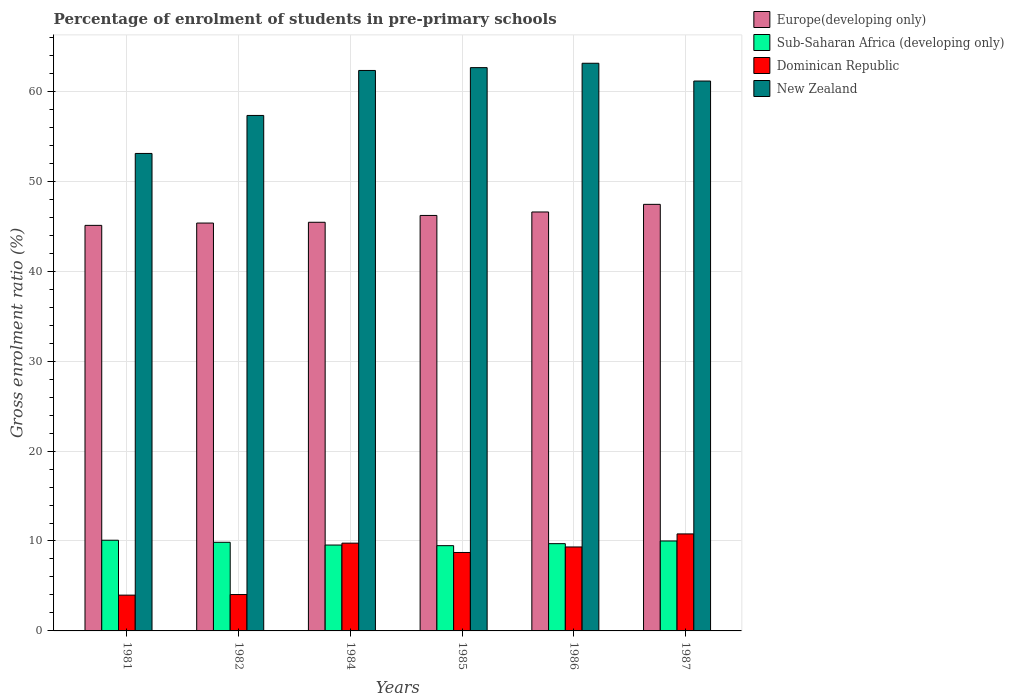How many different coloured bars are there?
Offer a terse response. 4. How many groups of bars are there?
Give a very brief answer. 6. Are the number of bars per tick equal to the number of legend labels?
Offer a terse response. Yes. Are the number of bars on each tick of the X-axis equal?
Give a very brief answer. Yes. How many bars are there on the 5th tick from the left?
Provide a succinct answer. 4. How many bars are there on the 5th tick from the right?
Keep it short and to the point. 4. In how many cases, is the number of bars for a given year not equal to the number of legend labels?
Offer a terse response. 0. What is the percentage of students enrolled in pre-primary schools in Sub-Saharan Africa (developing only) in 1982?
Keep it short and to the point. 9.86. Across all years, what is the maximum percentage of students enrolled in pre-primary schools in Dominican Republic?
Give a very brief answer. 10.79. Across all years, what is the minimum percentage of students enrolled in pre-primary schools in Sub-Saharan Africa (developing only)?
Give a very brief answer. 9.48. In which year was the percentage of students enrolled in pre-primary schools in Europe(developing only) maximum?
Offer a terse response. 1987. What is the total percentage of students enrolled in pre-primary schools in Europe(developing only) in the graph?
Keep it short and to the point. 276.12. What is the difference between the percentage of students enrolled in pre-primary schools in Dominican Republic in 1984 and that in 1985?
Provide a succinct answer. 1.04. What is the difference between the percentage of students enrolled in pre-primary schools in Dominican Republic in 1986 and the percentage of students enrolled in pre-primary schools in New Zealand in 1985?
Ensure brevity in your answer.  -53.3. What is the average percentage of students enrolled in pre-primary schools in Europe(developing only) per year?
Provide a short and direct response. 46.02. In the year 1981, what is the difference between the percentage of students enrolled in pre-primary schools in New Zealand and percentage of students enrolled in pre-primary schools in Dominican Republic?
Your response must be concise. 49.12. In how many years, is the percentage of students enrolled in pre-primary schools in New Zealand greater than 36 %?
Your response must be concise. 6. What is the ratio of the percentage of students enrolled in pre-primary schools in Dominican Republic in 1981 to that in 1982?
Your response must be concise. 0.98. Is the percentage of students enrolled in pre-primary schools in Europe(developing only) in 1982 less than that in 1986?
Your answer should be compact. Yes. Is the difference between the percentage of students enrolled in pre-primary schools in New Zealand in 1982 and 1986 greater than the difference between the percentage of students enrolled in pre-primary schools in Dominican Republic in 1982 and 1986?
Provide a succinct answer. No. What is the difference between the highest and the second highest percentage of students enrolled in pre-primary schools in Sub-Saharan Africa (developing only)?
Your response must be concise. 0.08. What is the difference between the highest and the lowest percentage of students enrolled in pre-primary schools in Dominican Republic?
Provide a succinct answer. 6.81. In how many years, is the percentage of students enrolled in pre-primary schools in New Zealand greater than the average percentage of students enrolled in pre-primary schools in New Zealand taken over all years?
Your response must be concise. 4. Is it the case that in every year, the sum of the percentage of students enrolled in pre-primary schools in Dominican Republic and percentage of students enrolled in pre-primary schools in Europe(developing only) is greater than the sum of percentage of students enrolled in pre-primary schools in New Zealand and percentage of students enrolled in pre-primary schools in Sub-Saharan Africa (developing only)?
Make the answer very short. Yes. What does the 4th bar from the left in 1984 represents?
Offer a very short reply. New Zealand. What does the 3rd bar from the right in 1987 represents?
Your response must be concise. Sub-Saharan Africa (developing only). Is it the case that in every year, the sum of the percentage of students enrolled in pre-primary schools in Dominican Republic and percentage of students enrolled in pre-primary schools in Sub-Saharan Africa (developing only) is greater than the percentage of students enrolled in pre-primary schools in New Zealand?
Give a very brief answer. No. How many bars are there?
Give a very brief answer. 24. Are all the bars in the graph horizontal?
Keep it short and to the point. No. How many years are there in the graph?
Ensure brevity in your answer.  6. Are the values on the major ticks of Y-axis written in scientific E-notation?
Ensure brevity in your answer.  No. Does the graph contain grids?
Your response must be concise. Yes. What is the title of the graph?
Provide a short and direct response. Percentage of enrolment of students in pre-primary schools. What is the label or title of the X-axis?
Offer a very short reply. Years. What is the label or title of the Y-axis?
Offer a very short reply. Gross enrolment ratio (%). What is the Gross enrolment ratio (%) of Europe(developing only) in 1981?
Make the answer very short. 45.1. What is the Gross enrolment ratio (%) of Sub-Saharan Africa (developing only) in 1981?
Your answer should be very brief. 10.09. What is the Gross enrolment ratio (%) of Dominican Republic in 1981?
Provide a short and direct response. 3.98. What is the Gross enrolment ratio (%) in New Zealand in 1981?
Your answer should be compact. 53.1. What is the Gross enrolment ratio (%) of Europe(developing only) in 1982?
Offer a very short reply. 45.35. What is the Gross enrolment ratio (%) in Sub-Saharan Africa (developing only) in 1982?
Keep it short and to the point. 9.86. What is the Gross enrolment ratio (%) in Dominican Republic in 1982?
Give a very brief answer. 4.05. What is the Gross enrolment ratio (%) in New Zealand in 1982?
Provide a succinct answer. 57.32. What is the Gross enrolment ratio (%) of Europe(developing only) in 1984?
Keep it short and to the point. 45.44. What is the Gross enrolment ratio (%) in Sub-Saharan Africa (developing only) in 1984?
Your response must be concise. 9.55. What is the Gross enrolment ratio (%) in Dominican Republic in 1984?
Your answer should be compact. 9.76. What is the Gross enrolment ratio (%) in New Zealand in 1984?
Your answer should be very brief. 62.32. What is the Gross enrolment ratio (%) in Europe(developing only) in 1985?
Provide a short and direct response. 46.2. What is the Gross enrolment ratio (%) of Sub-Saharan Africa (developing only) in 1985?
Ensure brevity in your answer.  9.48. What is the Gross enrolment ratio (%) in Dominican Republic in 1985?
Your answer should be very brief. 8.72. What is the Gross enrolment ratio (%) of New Zealand in 1985?
Offer a very short reply. 62.64. What is the Gross enrolment ratio (%) in Europe(developing only) in 1986?
Offer a very short reply. 46.59. What is the Gross enrolment ratio (%) in Sub-Saharan Africa (developing only) in 1986?
Provide a succinct answer. 9.7. What is the Gross enrolment ratio (%) of Dominican Republic in 1986?
Give a very brief answer. 9.34. What is the Gross enrolment ratio (%) of New Zealand in 1986?
Make the answer very short. 63.12. What is the Gross enrolment ratio (%) of Europe(developing only) in 1987?
Keep it short and to the point. 47.43. What is the Gross enrolment ratio (%) of Sub-Saharan Africa (developing only) in 1987?
Offer a terse response. 10. What is the Gross enrolment ratio (%) in Dominican Republic in 1987?
Make the answer very short. 10.79. What is the Gross enrolment ratio (%) in New Zealand in 1987?
Provide a succinct answer. 61.15. Across all years, what is the maximum Gross enrolment ratio (%) in Europe(developing only)?
Your response must be concise. 47.43. Across all years, what is the maximum Gross enrolment ratio (%) of Sub-Saharan Africa (developing only)?
Offer a very short reply. 10.09. Across all years, what is the maximum Gross enrolment ratio (%) of Dominican Republic?
Provide a short and direct response. 10.79. Across all years, what is the maximum Gross enrolment ratio (%) of New Zealand?
Provide a short and direct response. 63.12. Across all years, what is the minimum Gross enrolment ratio (%) of Europe(developing only)?
Your response must be concise. 45.1. Across all years, what is the minimum Gross enrolment ratio (%) in Sub-Saharan Africa (developing only)?
Ensure brevity in your answer.  9.48. Across all years, what is the minimum Gross enrolment ratio (%) in Dominican Republic?
Make the answer very short. 3.98. Across all years, what is the minimum Gross enrolment ratio (%) of New Zealand?
Provide a succinct answer. 53.1. What is the total Gross enrolment ratio (%) of Europe(developing only) in the graph?
Your response must be concise. 276.12. What is the total Gross enrolment ratio (%) of Sub-Saharan Africa (developing only) in the graph?
Offer a very short reply. 58.68. What is the total Gross enrolment ratio (%) in Dominican Republic in the graph?
Make the answer very short. 46.63. What is the total Gross enrolment ratio (%) in New Zealand in the graph?
Your answer should be compact. 359.65. What is the difference between the Gross enrolment ratio (%) in Europe(developing only) in 1981 and that in 1982?
Make the answer very short. -0.26. What is the difference between the Gross enrolment ratio (%) in Sub-Saharan Africa (developing only) in 1981 and that in 1982?
Provide a short and direct response. 0.23. What is the difference between the Gross enrolment ratio (%) of Dominican Republic in 1981 and that in 1982?
Provide a succinct answer. -0.07. What is the difference between the Gross enrolment ratio (%) of New Zealand in 1981 and that in 1982?
Offer a very short reply. -4.22. What is the difference between the Gross enrolment ratio (%) in Europe(developing only) in 1981 and that in 1984?
Your answer should be compact. -0.34. What is the difference between the Gross enrolment ratio (%) of Sub-Saharan Africa (developing only) in 1981 and that in 1984?
Make the answer very short. 0.54. What is the difference between the Gross enrolment ratio (%) of Dominican Republic in 1981 and that in 1984?
Your answer should be very brief. -5.78. What is the difference between the Gross enrolment ratio (%) of New Zealand in 1981 and that in 1984?
Offer a terse response. -9.23. What is the difference between the Gross enrolment ratio (%) in Europe(developing only) in 1981 and that in 1985?
Your answer should be very brief. -1.1. What is the difference between the Gross enrolment ratio (%) in Sub-Saharan Africa (developing only) in 1981 and that in 1985?
Ensure brevity in your answer.  0.61. What is the difference between the Gross enrolment ratio (%) in Dominican Republic in 1981 and that in 1985?
Ensure brevity in your answer.  -4.74. What is the difference between the Gross enrolment ratio (%) of New Zealand in 1981 and that in 1985?
Offer a terse response. -9.54. What is the difference between the Gross enrolment ratio (%) of Europe(developing only) in 1981 and that in 1986?
Give a very brief answer. -1.49. What is the difference between the Gross enrolment ratio (%) of Sub-Saharan Africa (developing only) in 1981 and that in 1986?
Offer a very short reply. 0.38. What is the difference between the Gross enrolment ratio (%) in Dominican Republic in 1981 and that in 1986?
Your answer should be compact. -5.36. What is the difference between the Gross enrolment ratio (%) of New Zealand in 1981 and that in 1986?
Your answer should be very brief. -10.03. What is the difference between the Gross enrolment ratio (%) in Europe(developing only) in 1981 and that in 1987?
Provide a succinct answer. -2.34. What is the difference between the Gross enrolment ratio (%) of Sub-Saharan Africa (developing only) in 1981 and that in 1987?
Give a very brief answer. 0.08. What is the difference between the Gross enrolment ratio (%) of Dominican Republic in 1981 and that in 1987?
Your answer should be very brief. -6.81. What is the difference between the Gross enrolment ratio (%) of New Zealand in 1981 and that in 1987?
Your answer should be very brief. -8.05. What is the difference between the Gross enrolment ratio (%) in Europe(developing only) in 1982 and that in 1984?
Make the answer very short. -0.09. What is the difference between the Gross enrolment ratio (%) of Sub-Saharan Africa (developing only) in 1982 and that in 1984?
Your answer should be compact. 0.31. What is the difference between the Gross enrolment ratio (%) in Dominican Republic in 1982 and that in 1984?
Ensure brevity in your answer.  -5.72. What is the difference between the Gross enrolment ratio (%) of New Zealand in 1982 and that in 1984?
Provide a short and direct response. -5. What is the difference between the Gross enrolment ratio (%) of Europe(developing only) in 1982 and that in 1985?
Offer a terse response. -0.85. What is the difference between the Gross enrolment ratio (%) in Sub-Saharan Africa (developing only) in 1982 and that in 1985?
Provide a short and direct response. 0.38. What is the difference between the Gross enrolment ratio (%) of Dominican Republic in 1982 and that in 1985?
Ensure brevity in your answer.  -4.68. What is the difference between the Gross enrolment ratio (%) of New Zealand in 1982 and that in 1985?
Provide a short and direct response. -5.32. What is the difference between the Gross enrolment ratio (%) in Europe(developing only) in 1982 and that in 1986?
Provide a succinct answer. -1.23. What is the difference between the Gross enrolment ratio (%) of Sub-Saharan Africa (developing only) in 1982 and that in 1986?
Your answer should be very brief. 0.15. What is the difference between the Gross enrolment ratio (%) of Dominican Republic in 1982 and that in 1986?
Give a very brief answer. -5.29. What is the difference between the Gross enrolment ratio (%) of New Zealand in 1982 and that in 1986?
Offer a terse response. -5.8. What is the difference between the Gross enrolment ratio (%) of Europe(developing only) in 1982 and that in 1987?
Ensure brevity in your answer.  -2.08. What is the difference between the Gross enrolment ratio (%) in Sub-Saharan Africa (developing only) in 1982 and that in 1987?
Your response must be concise. -0.15. What is the difference between the Gross enrolment ratio (%) of Dominican Republic in 1982 and that in 1987?
Your answer should be very brief. -6.74. What is the difference between the Gross enrolment ratio (%) of New Zealand in 1982 and that in 1987?
Your answer should be compact. -3.83. What is the difference between the Gross enrolment ratio (%) in Europe(developing only) in 1984 and that in 1985?
Ensure brevity in your answer.  -0.76. What is the difference between the Gross enrolment ratio (%) in Sub-Saharan Africa (developing only) in 1984 and that in 1985?
Your answer should be very brief. 0.07. What is the difference between the Gross enrolment ratio (%) of Dominican Republic in 1984 and that in 1985?
Ensure brevity in your answer.  1.04. What is the difference between the Gross enrolment ratio (%) of New Zealand in 1984 and that in 1985?
Provide a succinct answer. -0.31. What is the difference between the Gross enrolment ratio (%) of Europe(developing only) in 1984 and that in 1986?
Your answer should be very brief. -1.14. What is the difference between the Gross enrolment ratio (%) in Sub-Saharan Africa (developing only) in 1984 and that in 1986?
Keep it short and to the point. -0.15. What is the difference between the Gross enrolment ratio (%) of Dominican Republic in 1984 and that in 1986?
Give a very brief answer. 0.42. What is the difference between the Gross enrolment ratio (%) in New Zealand in 1984 and that in 1986?
Provide a short and direct response. -0.8. What is the difference between the Gross enrolment ratio (%) in Europe(developing only) in 1984 and that in 1987?
Offer a terse response. -1.99. What is the difference between the Gross enrolment ratio (%) in Sub-Saharan Africa (developing only) in 1984 and that in 1987?
Give a very brief answer. -0.45. What is the difference between the Gross enrolment ratio (%) of Dominican Republic in 1984 and that in 1987?
Keep it short and to the point. -1.03. What is the difference between the Gross enrolment ratio (%) in New Zealand in 1984 and that in 1987?
Provide a short and direct response. 1.18. What is the difference between the Gross enrolment ratio (%) in Europe(developing only) in 1985 and that in 1986?
Your response must be concise. -0.39. What is the difference between the Gross enrolment ratio (%) in Sub-Saharan Africa (developing only) in 1985 and that in 1986?
Ensure brevity in your answer.  -0.22. What is the difference between the Gross enrolment ratio (%) in Dominican Republic in 1985 and that in 1986?
Your answer should be very brief. -0.61. What is the difference between the Gross enrolment ratio (%) in New Zealand in 1985 and that in 1986?
Keep it short and to the point. -0.49. What is the difference between the Gross enrolment ratio (%) in Europe(developing only) in 1985 and that in 1987?
Offer a terse response. -1.23. What is the difference between the Gross enrolment ratio (%) in Sub-Saharan Africa (developing only) in 1985 and that in 1987?
Your response must be concise. -0.52. What is the difference between the Gross enrolment ratio (%) in Dominican Republic in 1985 and that in 1987?
Make the answer very short. -2.06. What is the difference between the Gross enrolment ratio (%) in New Zealand in 1985 and that in 1987?
Your answer should be compact. 1.49. What is the difference between the Gross enrolment ratio (%) of Europe(developing only) in 1986 and that in 1987?
Your response must be concise. -0.85. What is the difference between the Gross enrolment ratio (%) in Sub-Saharan Africa (developing only) in 1986 and that in 1987?
Provide a succinct answer. -0.3. What is the difference between the Gross enrolment ratio (%) in Dominican Republic in 1986 and that in 1987?
Your response must be concise. -1.45. What is the difference between the Gross enrolment ratio (%) of New Zealand in 1986 and that in 1987?
Your answer should be compact. 1.98. What is the difference between the Gross enrolment ratio (%) in Europe(developing only) in 1981 and the Gross enrolment ratio (%) in Sub-Saharan Africa (developing only) in 1982?
Ensure brevity in your answer.  35.24. What is the difference between the Gross enrolment ratio (%) of Europe(developing only) in 1981 and the Gross enrolment ratio (%) of Dominican Republic in 1982?
Your response must be concise. 41.05. What is the difference between the Gross enrolment ratio (%) in Europe(developing only) in 1981 and the Gross enrolment ratio (%) in New Zealand in 1982?
Offer a terse response. -12.22. What is the difference between the Gross enrolment ratio (%) of Sub-Saharan Africa (developing only) in 1981 and the Gross enrolment ratio (%) of Dominican Republic in 1982?
Offer a very short reply. 6.04. What is the difference between the Gross enrolment ratio (%) in Sub-Saharan Africa (developing only) in 1981 and the Gross enrolment ratio (%) in New Zealand in 1982?
Make the answer very short. -47.23. What is the difference between the Gross enrolment ratio (%) of Dominican Republic in 1981 and the Gross enrolment ratio (%) of New Zealand in 1982?
Your answer should be compact. -53.34. What is the difference between the Gross enrolment ratio (%) of Europe(developing only) in 1981 and the Gross enrolment ratio (%) of Sub-Saharan Africa (developing only) in 1984?
Provide a succinct answer. 35.55. What is the difference between the Gross enrolment ratio (%) in Europe(developing only) in 1981 and the Gross enrolment ratio (%) in Dominican Republic in 1984?
Give a very brief answer. 35.34. What is the difference between the Gross enrolment ratio (%) in Europe(developing only) in 1981 and the Gross enrolment ratio (%) in New Zealand in 1984?
Provide a short and direct response. -17.23. What is the difference between the Gross enrolment ratio (%) in Sub-Saharan Africa (developing only) in 1981 and the Gross enrolment ratio (%) in Dominican Republic in 1984?
Offer a terse response. 0.33. What is the difference between the Gross enrolment ratio (%) in Sub-Saharan Africa (developing only) in 1981 and the Gross enrolment ratio (%) in New Zealand in 1984?
Offer a very short reply. -52.24. What is the difference between the Gross enrolment ratio (%) of Dominican Republic in 1981 and the Gross enrolment ratio (%) of New Zealand in 1984?
Make the answer very short. -58.34. What is the difference between the Gross enrolment ratio (%) of Europe(developing only) in 1981 and the Gross enrolment ratio (%) of Sub-Saharan Africa (developing only) in 1985?
Provide a succinct answer. 35.62. What is the difference between the Gross enrolment ratio (%) in Europe(developing only) in 1981 and the Gross enrolment ratio (%) in Dominican Republic in 1985?
Offer a very short reply. 36.37. What is the difference between the Gross enrolment ratio (%) of Europe(developing only) in 1981 and the Gross enrolment ratio (%) of New Zealand in 1985?
Ensure brevity in your answer.  -17.54. What is the difference between the Gross enrolment ratio (%) in Sub-Saharan Africa (developing only) in 1981 and the Gross enrolment ratio (%) in Dominican Republic in 1985?
Your answer should be compact. 1.36. What is the difference between the Gross enrolment ratio (%) of Sub-Saharan Africa (developing only) in 1981 and the Gross enrolment ratio (%) of New Zealand in 1985?
Your answer should be compact. -52.55. What is the difference between the Gross enrolment ratio (%) of Dominican Republic in 1981 and the Gross enrolment ratio (%) of New Zealand in 1985?
Keep it short and to the point. -58.66. What is the difference between the Gross enrolment ratio (%) of Europe(developing only) in 1981 and the Gross enrolment ratio (%) of Sub-Saharan Africa (developing only) in 1986?
Your answer should be very brief. 35.39. What is the difference between the Gross enrolment ratio (%) of Europe(developing only) in 1981 and the Gross enrolment ratio (%) of Dominican Republic in 1986?
Provide a short and direct response. 35.76. What is the difference between the Gross enrolment ratio (%) in Europe(developing only) in 1981 and the Gross enrolment ratio (%) in New Zealand in 1986?
Your answer should be very brief. -18.03. What is the difference between the Gross enrolment ratio (%) in Sub-Saharan Africa (developing only) in 1981 and the Gross enrolment ratio (%) in Dominican Republic in 1986?
Offer a very short reply. 0.75. What is the difference between the Gross enrolment ratio (%) of Sub-Saharan Africa (developing only) in 1981 and the Gross enrolment ratio (%) of New Zealand in 1986?
Offer a very short reply. -53.04. What is the difference between the Gross enrolment ratio (%) in Dominican Republic in 1981 and the Gross enrolment ratio (%) in New Zealand in 1986?
Keep it short and to the point. -59.14. What is the difference between the Gross enrolment ratio (%) in Europe(developing only) in 1981 and the Gross enrolment ratio (%) in Sub-Saharan Africa (developing only) in 1987?
Offer a very short reply. 35.1. What is the difference between the Gross enrolment ratio (%) in Europe(developing only) in 1981 and the Gross enrolment ratio (%) in Dominican Republic in 1987?
Your response must be concise. 34.31. What is the difference between the Gross enrolment ratio (%) in Europe(developing only) in 1981 and the Gross enrolment ratio (%) in New Zealand in 1987?
Provide a succinct answer. -16.05. What is the difference between the Gross enrolment ratio (%) of Sub-Saharan Africa (developing only) in 1981 and the Gross enrolment ratio (%) of Dominican Republic in 1987?
Make the answer very short. -0.7. What is the difference between the Gross enrolment ratio (%) of Sub-Saharan Africa (developing only) in 1981 and the Gross enrolment ratio (%) of New Zealand in 1987?
Provide a short and direct response. -51.06. What is the difference between the Gross enrolment ratio (%) in Dominican Republic in 1981 and the Gross enrolment ratio (%) in New Zealand in 1987?
Your answer should be very brief. -57.17. What is the difference between the Gross enrolment ratio (%) in Europe(developing only) in 1982 and the Gross enrolment ratio (%) in Sub-Saharan Africa (developing only) in 1984?
Keep it short and to the point. 35.8. What is the difference between the Gross enrolment ratio (%) in Europe(developing only) in 1982 and the Gross enrolment ratio (%) in Dominican Republic in 1984?
Your response must be concise. 35.59. What is the difference between the Gross enrolment ratio (%) in Europe(developing only) in 1982 and the Gross enrolment ratio (%) in New Zealand in 1984?
Make the answer very short. -16.97. What is the difference between the Gross enrolment ratio (%) of Sub-Saharan Africa (developing only) in 1982 and the Gross enrolment ratio (%) of Dominican Republic in 1984?
Your answer should be compact. 0.1. What is the difference between the Gross enrolment ratio (%) in Sub-Saharan Africa (developing only) in 1982 and the Gross enrolment ratio (%) in New Zealand in 1984?
Your answer should be very brief. -52.47. What is the difference between the Gross enrolment ratio (%) in Dominican Republic in 1982 and the Gross enrolment ratio (%) in New Zealand in 1984?
Your answer should be compact. -58.28. What is the difference between the Gross enrolment ratio (%) in Europe(developing only) in 1982 and the Gross enrolment ratio (%) in Sub-Saharan Africa (developing only) in 1985?
Ensure brevity in your answer.  35.87. What is the difference between the Gross enrolment ratio (%) in Europe(developing only) in 1982 and the Gross enrolment ratio (%) in Dominican Republic in 1985?
Your answer should be very brief. 36.63. What is the difference between the Gross enrolment ratio (%) of Europe(developing only) in 1982 and the Gross enrolment ratio (%) of New Zealand in 1985?
Offer a terse response. -17.28. What is the difference between the Gross enrolment ratio (%) of Sub-Saharan Africa (developing only) in 1982 and the Gross enrolment ratio (%) of Dominican Republic in 1985?
Your answer should be compact. 1.13. What is the difference between the Gross enrolment ratio (%) in Sub-Saharan Africa (developing only) in 1982 and the Gross enrolment ratio (%) in New Zealand in 1985?
Provide a short and direct response. -52.78. What is the difference between the Gross enrolment ratio (%) in Dominican Republic in 1982 and the Gross enrolment ratio (%) in New Zealand in 1985?
Keep it short and to the point. -58.59. What is the difference between the Gross enrolment ratio (%) in Europe(developing only) in 1982 and the Gross enrolment ratio (%) in Sub-Saharan Africa (developing only) in 1986?
Keep it short and to the point. 35.65. What is the difference between the Gross enrolment ratio (%) in Europe(developing only) in 1982 and the Gross enrolment ratio (%) in Dominican Republic in 1986?
Provide a succinct answer. 36.02. What is the difference between the Gross enrolment ratio (%) of Europe(developing only) in 1982 and the Gross enrolment ratio (%) of New Zealand in 1986?
Give a very brief answer. -17.77. What is the difference between the Gross enrolment ratio (%) in Sub-Saharan Africa (developing only) in 1982 and the Gross enrolment ratio (%) in Dominican Republic in 1986?
Your answer should be compact. 0.52. What is the difference between the Gross enrolment ratio (%) of Sub-Saharan Africa (developing only) in 1982 and the Gross enrolment ratio (%) of New Zealand in 1986?
Your answer should be very brief. -53.27. What is the difference between the Gross enrolment ratio (%) in Dominican Republic in 1982 and the Gross enrolment ratio (%) in New Zealand in 1986?
Offer a very short reply. -59.08. What is the difference between the Gross enrolment ratio (%) in Europe(developing only) in 1982 and the Gross enrolment ratio (%) in Sub-Saharan Africa (developing only) in 1987?
Keep it short and to the point. 35.35. What is the difference between the Gross enrolment ratio (%) in Europe(developing only) in 1982 and the Gross enrolment ratio (%) in Dominican Republic in 1987?
Your response must be concise. 34.57. What is the difference between the Gross enrolment ratio (%) in Europe(developing only) in 1982 and the Gross enrolment ratio (%) in New Zealand in 1987?
Your response must be concise. -15.79. What is the difference between the Gross enrolment ratio (%) of Sub-Saharan Africa (developing only) in 1982 and the Gross enrolment ratio (%) of Dominican Republic in 1987?
Your answer should be very brief. -0.93. What is the difference between the Gross enrolment ratio (%) in Sub-Saharan Africa (developing only) in 1982 and the Gross enrolment ratio (%) in New Zealand in 1987?
Your answer should be compact. -51.29. What is the difference between the Gross enrolment ratio (%) of Dominican Republic in 1982 and the Gross enrolment ratio (%) of New Zealand in 1987?
Keep it short and to the point. -57.1. What is the difference between the Gross enrolment ratio (%) of Europe(developing only) in 1984 and the Gross enrolment ratio (%) of Sub-Saharan Africa (developing only) in 1985?
Your answer should be very brief. 35.96. What is the difference between the Gross enrolment ratio (%) of Europe(developing only) in 1984 and the Gross enrolment ratio (%) of Dominican Republic in 1985?
Your answer should be very brief. 36.72. What is the difference between the Gross enrolment ratio (%) of Europe(developing only) in 1984 and the Gross enrolment ratio (%) of New Zealand in 1985?
Your response must be concise. -17.2. What is the difference between the Gross enrolment ratio (%) of Sub-Saharan Africa (developing only) in 1984 and the Gross enrolment ratio (%) of Dominican Republic in 1985?
Keep it short and to the point. 0.83. What is the difference between the Gross enrolment ratio (%) of Sub-Saharan Africa (developing only) in 1984 and the Gross enrolment ratio (%) of New Zealand in 1985?
Keep it short and to the point. -53.09. What is the difference between the Gross enrolment ratio (%) of Dominican Republic in 1984 and the Gross enrolment ratio (%) of New Zealand in 1985?
Provide a succinct answer. -52.88. What is the difference between the Gross enrolment ratio (%) of Europe(developing only) in 1984 and the Gross enrolment ratio (%) of Sub-Saharan Africa (developing only) in 1986?
Your response must be concise. 35.74. What is the difference between the Gross enrolment ratio (%) in Europe(developing only) in 1984 and the Gross enrolment ratio (%) in Dominican Republic in 1986?
Ensure brevity in your answer.  36.11. What is the difference between the Gross enrolment ratio (%) in Europe(developing only) in 1984 and the Gross enrolment ratio (%) in New Zealand in 1986?
Provide a short and direct response. -17.68. What is the difference between the Gross enrolment ratio (%) in Sub-Saharan Africa (developing only) in 1984 and the Gross enrolment ratio (%) in Dominican Republic in 1986?
Your response must be concise. 0.21. What is the difference between the Gross enrolment ratio (%) of Sub-Saharan Africa (developing only) in 1984 and the Gross enrolment ratio (%) of New Zealand in 1986?
Offer a very short reply. -53.57. What is the difference between the Gross enrolment ratio (%) in Dominican Republic in 1984 and the Gross enrolment ratio (%) in New Zealand in 1986?
Make the answer very short. -53.36. What is the difference between the Gross enrolment ratio (%) of Europe(developing only) in 1984 and the Gross enrolment ratio (%) of Sub-Saharan Africa (developing only) in 1987?
Provide a short and direct response. 35.44. What is the difference between the Gross enrolment ratio (%) of Europe(developing only) in 1984 and the Gross enrolment ratio (%) of Dominican Republic in 1987?
Your answer should be very brief. 34.65. What is the difference between the Gross enrolment ratio (%) in Europe(developing only) in 1984 and the Gross enrolment ratio (%) in New Zealand in 1987?
Your response must be concise. -15.7. What is the difference between the Gross enrolment ratio (%) in Sub-Saharan Africa (developing only) in 1984 and the Gross enrolment ratio (%) in Dominican Republic in 1987?
Offer a terse response. -1.24. What is the difference between the Gross enrolment ratio (%) of Sub-Saharan Africa (developing only) in 1984 and the Gross enrolment ratio (%) of New Zealand in 1987?
Give a very brief answer. -51.6. What is the difference between the Gross enrolment ratio (%) in Dominican Republic in 1984 and the Gross enrolment ratio (%) in New Zealand in 1987?
Your response must be concise. -51.39. What is the difference between the Gross enrolment ratio (%) in Europe(developing only) in 1985 and the Gross enrolment ratio (%) in Sub-Saharan Africa (developing only) in 1986?
Give a very brief answer. 36.5. What is the difference between the Gross enrolment ratio (%) in Europe(developing only) in 1985 and the Gross enrolment ratio (%) in Dominican Republic in 1986?
Provide a short and direct response. 36.86. What is the difference between the Gross enrolment ratio (%) in Europe(developing only) in 1985 and the Gross enrolment ratio (%) in New Zealand in 1986?
Make the answer very short. -16.92. What is the difference between the Gross enrolment ratio (%) of Sub-Saharan Africa (developing only) in 1985 and the Gross enrolment ratio (%) of Dominican Republic in 1986?
Give a very brief answer. 0.15. What is the difference between the Gross enrolment ratio (%) in Sub-Saharan Africa (developing only) in 1985 and the Gross enrolment ratio (%) in New Zealand in 1986?
Make the answer very short. -53.64. What is the difference between the Gross enrolment ratio (%) of Dominican Republic in 1985 and the Gross enrolment ratio (%) of New Zealand in 1986?
Keep it short and to the point. -54.4. What is the difference between the Gross enrolment ratio (%) of Europe(developing only) in 1985 and the Gross enrolment ratio (%) of Sub-Saharan Africa (developing only) in 1987?
Your answer should be very brief. 36.2. What is the difference between the Gross enrolment ratio (%) in Europe(developing only) in 1985 and the Gross enrolment ratio (%) in Dominican Republic in 1987?
Make the answer very short. 35.41. What is the difference between the Gross enrolment ratio (%) of Europe(developing only) in 1985 and the Gross enrolment ratio (%) of New Zealand in 1987?
Provide a short and direct response. -14.95. What is the difference between the Gross enrolment ratio (%) of Sub-Saharan Africa (developing only) in 1985 and the Gross enrolment ratio (%) of Dominican Republic in 1987?
Give a very brief answer. -1.31. What is the difference between the Gross enrolment ratio (%) in Sub-Saharan Africa (developing only) in 1985 and the Gross enrolment ratio (%) in New Zealand in 1987?
Give a very brief answer. -51.67. What is the difference between the Gross enrolment ratio (%) in Dominican Republic in 1985 and the Gross enrolment ratio (%) in New Zealand in 1987?
Your response must be concise. -52.42. What is the difference between the Gross enrolment ratio (%) of Europe(developing only) in 1986 and the Gross enrolment ratio (%) of Sub-Saharan Africa (developing only) in 1987?
Provide a succinct answer. 36.58. What is the difference between the Gross enrolment ratio (%) of Europe(developing only) in 1986 and the Gross enrolment ratio (%) of Dominican Republic in 1987?
Your response must be concise. 35.8. What is the difference between the Gross enrolment ratio (%) in Europe(developing only) in 1986 and the Gross enrolment ratio (%) in New Zealand in 1987?
Provide a short and direct response. -14.56. What is the difference between the Gross enrolment ratio (%) of Sub-Saharan Africa (developing only) in 1986 and the Gross enrolment ratio (%) of Dominican Republic in 1987?
Offer a very short reply. -1.08. What is the difference between the Gross enrolment ratio (%) of Sub-Saharan Africa (developing only) in 1986 and the Gross enrolment ratio (%) of New Zealand in 1987?
Ensure brevity in your answer.  -51.44. What is the difference between the Gross enrolment ratio (%) of Dominican Republic in 1986 and the Gross enrolment ratio (%) of New Zealand in 1987?
Your response must be concise. -51.81. What is the average Gross enrolment ratio (%) of Europe(developing only) per year?
Make the answer very short. 46.02. What is the average Gross enrolment ratio (%) in Sub-Saharan Africa (developing only) per year?
Your answer should be compact. 9.78. What is the average Gross enrolment ratio (%) of Dominican Republic per year?
Your answer should be compact. 7.77. What is the average Gross enrolment ratio (%) of New Zealand per year?
Provide a short and direct response. 59.94. In the year 1981, what is the difference between the Gross enrolment ratio (%) in Europe(developing only) and Gross enrolment ratio (%) in Sub-Saharan Africa (developing only)?
Offer a very short reply. 35.01. In the year 1981, what is the difference between the Gross enrolment ratio (%) of Europe(developing only) and Gross enrolment ratio (%) of Dominican Republic?
Offer a very short reply. 41.12. In the year 1981, what is the difference between the Gross enrolment ratio (%) in Europe(developing only) and Gross enrolment ratio (%) in New Zealand?
Ensure brevity in your answer.  -8. In the year 1981, what is the difference between the Gross enrolment ratio (%) of Sub-Saharan Africa (developing only) and Gross enrolment ratio (%) of Dominican Republic?
Offer a terse response. 6.11. In the year 1981, what is the difference between the Gross enrolment ratio (%) of Sub-Saharan Africa (developing only) and Gross enrolment ratio (%) of New Zealand?
Your answer should be compact. -43.01. In the year 1981, what is the difference between the Gross enrolment ratio (%) of Dominican Republic and Gross enrolment ratio (%) of New Zealand?
Give a very brief answer. -49.12. In the year 1982, what is the difference between the Gross enrolment ratio (%) of Europe(developing only) and Gross enrolment ratio (%) of Sub-Saharan Africa (developing only)?
Provide a short and direct response. 35.5. In the year 1982, what is the difference between the Gross enrolment ratio (%) of Europe(developing only) and Gross enrolment ratio (%) of Dominican Republic?
Provide a succinct answer. 41.31. In the year 1982, what is the difference between the Gross enrolment ratio (%) in Europe(developing only) and Gross enrolment ratio (%) in New Zealand?
Ensure brevity in your answer.  -11.97. In the year 1982, what is the difference between the Gross enrolment ratio (%) of Sub-Saharan Africa (developing only) and Gross enrolment ratio (%) of Dominican Republic?
Provide a succinct answer. 5.81. In the year 1982, what is the difference between the Gross enrolment ratio (%) in Sub-Saharan Africa (developing only) and Gross enrolment ratio (%) in New Zealand?
Your answer should be very brief. -47.46. In the year 1982, what is the difference between the Gross enrolment ratio (%) in Dominican Republic and Gross enrolment ratio (%) in New Zealand?
Your response must be concise. -53.27. In the year 1984, what is the difference between the Gross enrolment ratio (%) of Europe(developing only) and Gross enrolment ratio (%) of Sub-Saharan Africa (developing only)?
Your response must be concise. 35.89. In the year 1984, what is the difference between the Gross enrolment ratio (%) in Europe(developing only) and Gross enrolment ratio (%) in Dominican Republic?
Offer a terse response. 35.68. In the year 1984, what is the difference between the Gross enrolment ratio (%) of Europe(developing only) and Gross enrolment ratio (%) of New Zealand?
Your response must be concise. -16.88. In the year 1984, what is the difference between the Gross enrolment ratio (%) of Sub-Saharan Africa (developing only) and Gross enrolment ratio (%) of Dominican Republic?
Offer a terse response. -0.21. In the year 1984, what is the difference between the Gross enrolment ratio (%) of Sub-Saharan Africa (developing only) and Gross enrolment ratio (%) of New Zealand?
Offer a terse response. -52.77. In the year 1984, what is the difference between the Gross enrolment ratio (%) of Dominican Republic and Gross enrolment ratio (%) of New Zealand?
Ensure brevity in your answer.  -52.56. In the year 1985, what is the difference between the Gross enrolment ratio (%) in Europe(developing only) and Gross enrolment ratio (%) in Sub-Saharan Africa (developing only)?
Provide a succinct answer. 36.72. In the year 1985, what is the difference between the Gross enrolment ratio (%) of Europe(developing only) and Gross enrolment ratio (%) of Dominican Republic?
Your answer should be compact. 37.48. In the year 1985, what is the difference between the Gross enrolment ratio (%) of Europe(developing only) and Gross enrolment ratio (%) of New Zealand?
Your answer should be very brief. -16.44. In the year 1985, what is the difference between the Gross enrolment ratio (%) in Sub-Saharan Africa (developing only) and Gross enrolment ratio (%) in Dominican Republic?
Offer a very short reply. 0.76. In the year 1985, what is the difference between the Gross enrolment ratio (%) in Sub-Saharan Africa (developing only) and Gross enrolment ratio (%) in New Zealand?
Your answer should be compact. -53.16. In the year 1985, what is the difference between the Gross enrolment ratio (%) of Dominican Republic and Gross enrolment ratio (%) of New Zealand?
Offer a terse response. -53.91. In the year 1986, what is the difference between the Gross enrolment ratio (%) of Europe(developing only) and Gross enrolment ratio (%) of Sub-Saharan Africa (developing only)?
Keep it short and to the point. 36.88. In the year 1986, what is the difference between the Gross enrolment ratio (%) of Europe(developing only) and Gross enrolment ratio (%) of Dominican Republic?
Make the answer very short. 37.25. In the year 1986, what is the difference between the Gross enrolment ratio (%) in Europe(developing only) and Gross enrolment ratio (%) in New Zealand?
Ensure brevity in your answer.  -16.54. In the year 1986, what is the difference between the Gross enrolment ratio (%) of Sub-Saharan Africa (developing only) and Gross enrolment ratio (%) of Dominican Republic?
Offer a terse response. 0.37. In the year 1986, what is the difference between the Gross enrolment ratio (%) in Sub-Saharan Africa (developing only) and Gross enrolment ratio (%) in New Zealand?
Provide a short and direct response. -53.42. In the year 1986, what is the difference between the Gross enrolment ratio (%) in Dominican Republic and Gross enrolment ratio (%) in New Zealand?
Ensure brevity in your answer.  -53.79. In the year 1987, what is the difference between the Gross enrolment ratio (%) in Europe(developing only) and Gross enrolment ratio (%) in Sub-Saharan Africa (developing only)?
Keep it short and to the point. 37.43. In the year 1987, what is the difference between the Gross enrolment ratio (%) of Europe(developing only) and Gross enrolment ratio (%) of Dominican Republic?
Offer a very short reply. 36.65. In the year 1987, what is the difference between the Gross enrolment ratio (%) of Europe(developing only) and Gross enrolment ratio (%) of New Zealand?
Your answer should be compact. -13.71. In the year 1987, what is the difference between the Gross enrolment ratio (%) of Sub-Saharan Africa (developing only) and Gross enrolment ratio (%) of Dominican Republic?
Keep it short and to the point. -0.78. In the year 1987, what is the difference between the Gross enrolment ratio (%) in Sub-Saharan Africa (developing only) and Gross enrolment ratio (%) in New Zealand?
Ensure brevity in your answer.  -51.14. In the year 1987, what is the difference between the Gross enrolment ratio (%) in Dominican Republic and Gross enrolment ratio (%) in New Zealand?
Provide a succinct answer. -50.36. What is the ratio of the Gross enrolment ratio (%) in Sub-Saharan Africa (developing only) in 1981 to that in 1982?
Provide a succinct answer. 1.02. What is the ratio of the Gross enrolment ratio (%) of Dominican Republic in 1981 to that in 1982?
Offer a very short reply. 0.98. What is the ratio of the Gross enrolment ratio (%) in New Zealand in 1981 to that in 1982?
Your response must be concise. 0.93. What is the ratio of the Gross enrolment ratio (%) of Sub-Saharan Africa (developing only) in 1981 to that in 1984?
Make the answer very short. 1.06. What is the ratio of the Gross enrolment ratio (%) in Dominican Republic in 1981 to that in 1984?
Your response must be concise. 0.41. What is the ratio of the Gross enrolment ratio (%) of New Zealand in 1981 to that in 1984?
Keep it short and to the point. 0.85. What is the ratio of the Gross enrolment ratio (%) in Europe(developing only) in 1981 to that in 1985?
Keep it short and to the point. 0.98. What is the ratio of the Gross enrolment ratio (%) in Sub-Saharan Africa (developing only) in 1981 to that in 1985?
Provide a succinct answer. 1.06. What is the ratio of the Gross enrolment ratio (%) of Dominican Republic in 1981 to that in 1985?
Ensure brevity in your answer.  0.46. What is the ratio of the Gross enrolment ratio (%) in New Zealand in 1981 to that in 1985?
Your answer should be compact. 0.85. What is the ratio of the Gross enrolment ratio (%) of Europe(developing only) in 1981 to that in 1986?
Your answer should be very brief. 0.97. What is the ratio of the Gross enrolment ratio (%) of Sub-Saharan Africa (developing only) in 1981 to that in 1986?
Provide a succinct answer. 1.04. What is the ratio of the Gross enrolment ratio (%) in Dominican Republic in 1981 to that in 1986?
Provide a short and direct response. 0.43. What is the ratio of the Gross enrolment ratio (%) of New Zealand in 1981 to that in 1986?
Your answer should be compact. 0.84. What is the ratio of the Gross enrolment ratio (%) in Europe(developing only) in 1981 to that in 1987?
Provide a short and direct response. 0.95. What is the ratio of the Gross enrolment ratio (%) of Sub-Saharan Africa (developing only) in 1981 to that in 1987?
Provide a succinct answer. 1.01. What is the ratio of the Gross enrolment ratio (%) in Dominican Republic in 1981 to that in 1987?
Provide a short and direct response. 0.37. What is the ratio of the Gross enrolment ratio (%) of New Zealand in 1981 to that in 1987?
Offer a very short reply. 0.87. What is the ratio of the Gross enrolment ratio (%) of Sub-Saharan Africa (developing only) in 1982 to that in 1984?
Offer a very short reply. 1.03. What is the ratio of the Gross enrolment ratio (%) in Dominican Republic in 1982 to that in 1984?
Provide a short and direct response. 0.41. What is the ratio of the Gross enrolment ratio (%) in New Zealand in 1982 to that in 1984?
Provide a succinct answer. 0.92. What is the ratio of the Gross enrolment ratio (%) in Europe(developing only) in 1982 to that in 1985?
Give a very brief answer. 0.98. What is the ratio of the Gross enrolment ratio (%) of Sub-Saharan Africa (developing only) in 1982 to that in 1985?
Keep it short and to the point. 1.04. What is the ratio of the Gross enrolment ratio (%) of Dominican Republic in 1982 to that in 1985?
Make the answer very short. 0.46. What is the ratio of the Gross enrolment ratio (%) in New Zealand in 1982 to that in 1985?
Provide a short and direct response. 0.92. What is the ratio of the Gross enrolment ratio (%) in Europe(developing only) in 1982 to that in 1986?
Keep it short and to the point. 0.97. What is the ratio of the Gross enrolment ratio (%) of Sub-Saharan Africa (developing only) in 1982 to that in 1986?
Give a very brief answer. 1.02. What is the ratio of the Gross enrolment ratio (%) of Dominican Republic in 1982 to that in 1986?
Offer a terse response. 0.43. What is the ratio of the Gross enrolment ratio (%) of New Zealand in 1982 to that in 1986?
Make the answer very short. 0.91. What is the ratio of the Gross enrolment ratio (%) of Europe(developing only) in 1982 to that in 1987?
Offer a terse response. 0.96. What is the ratio of the Gross enrolment ratio (%) in Sub-Saharan Africa (developing only) in 1982 to that in 1987?
Ensure brevity in your answer.  0.99. What is the ratio of the Gross enrolment ratio (%) of Dominican Republic in 1982 to that in 1987?
Your answer should be compact. 0.38. What is the ratio of the Gross enrolment ratio (%) in New Zealand in 1982 to that in 1987?
Your response must be concise. 0.94. What is the ratio of the Gross enrolment ratio (%) of Europe(developing only) in 1984 to that in 1985?
Make the answer very short. 0.98. What is the ratio of the Gross enrolment ratio (%) in Sub-Saharan Africa (developing only) in 1984 to that in 1985?
Offer a very short reply. 1.01. What is the ratio of the Gross enrolment ratio (%) of Dominican Republic in 1984 to that in 1985?
Keep it short and to the point. 1.12. What is the ratio of the Gross enrolment ratio (%) of Europe(developing only) in 1984 to that in 1986?
Keep it short and to the point. 0.98. What is the ratio of the Gross enrolment ratio (%) in Sub-Saharan Africa (developing only) in 1984 to that in 1986?
Ensure brevity in your answer.  0.98. What is the ratio of the Gross enrolment ratio (%) of Dominican Republic in 1984 to that in 1986?
Your answer should be very brief. 1.05. What is the ratio of the Gross enrolment ratio (%) of New Zealand in 1984 to that in 1986?
Offer a terse response. 0.99. What is the ratio of the Gross enrolment ratio (%) in Europe(developing only) in 1984 to that in 1987?
Provide a succinct answer. 0.96. What is the ratio of the Gross enrolment ratio (%) in Sub-Saharan Africa (developing only) in 1984 to that in 1987?
Your answer should be very brief. 0.95. What is the ratio of the Gross enrolment ratio (%) in Dominican Republic in 1984 to that in 1987?
Give a very brief answer. 0.9. What is the ratio of the Gross enrolment ratio (%) in New Zealand in 1984 to that in 1987?
Keep it short and to the point. 1.02. What is the ratio of the Gross enrolment ratio (%) of Sub-Saharan Africa (developing only) in 1985 to that in 1986?
Provide a succinct answer. 0.98. What is the ratio of the Gross enrolment ratio (%) of Dominican Republic in 1985 to that in 1986?
Provide a short and direct response. 0.93. What is the ratio of the Gross enrolment ratio (%) in Europe(developing only) in 1985 to that in 1987?
Ensure brevity in your answer.  0.97. What is the ratio of the Gross enrolment ratio (%) of Sub-Saharan Africa (developing only) in 1985 to that in 1987?
Your answer should be compact. 0.95. What is the ratio of the Gross enrolment ratio (%) of Dominican Republic in 1985 to that in 1987?
Provide a succinct answer. 0.81. What is the ratio of the Gross enrolment ratio (%) in New Zealand in 1985 to that in 1987?
Provide a succinct answer. 1.02. What is the ratio of the Gross enrolment ratio (%) in Europe(developing only) in 1986 to that in 1987?
Ensure brevity in your answer.  0.98. What is the ratio of the Gross enrolment ratio (%) in Sub-Saharan Africa (developing only) in 1986 to that in 1987?
Offer a very short reply. 0.97. What is the ratio of the Gross enrolment ratio (%) of Dominican Republic in 1986 to that in 1987?
Your answer should be compact. 0.87. What is the ratio of the Gross enrolment ratio (%) in New Zealand in 1986 to that in 1987?
Your answer should be compact. 1.03. What is the difference between the highest and the second highest Gross enrolment ratio (%) of Europe(developing only)?
Your answer should be compact. 0.85. What is the difference between the highest and the second highest Gross enrolment ratio (%) of Sub-Saharan Africa (developing only)?
Your response must be concise. 0.08. What is the difference between the highest and the second highest Gross enrolment ratio (%) of Dominican Republic?
Offer a terse response. 1.03. What is the difference between the highest and the second highest Gross enrolment ratio (%) in New Zealand?
Make the answer very short. 0.49. What is the difference between the highest and the lowest Gross enrolment ratio (%) in Europe(developing only)?
Make the answer very short. 2.34. What is the difference between the highest and the lowest Gross enrolment ratio (%) of Sub-Saharan Africa (developing only)?
Offer a terse response. 0.61. What is the difference between the highest and the lowest Gross enrolment ratio (%) of Dominican Republic?
Keep it short and to the point. 6.81. What is the difference between the highest and the lowest Gross enrolment ratio (%) in New Zealand?
Ensure brevity in your answer.  10.03. 